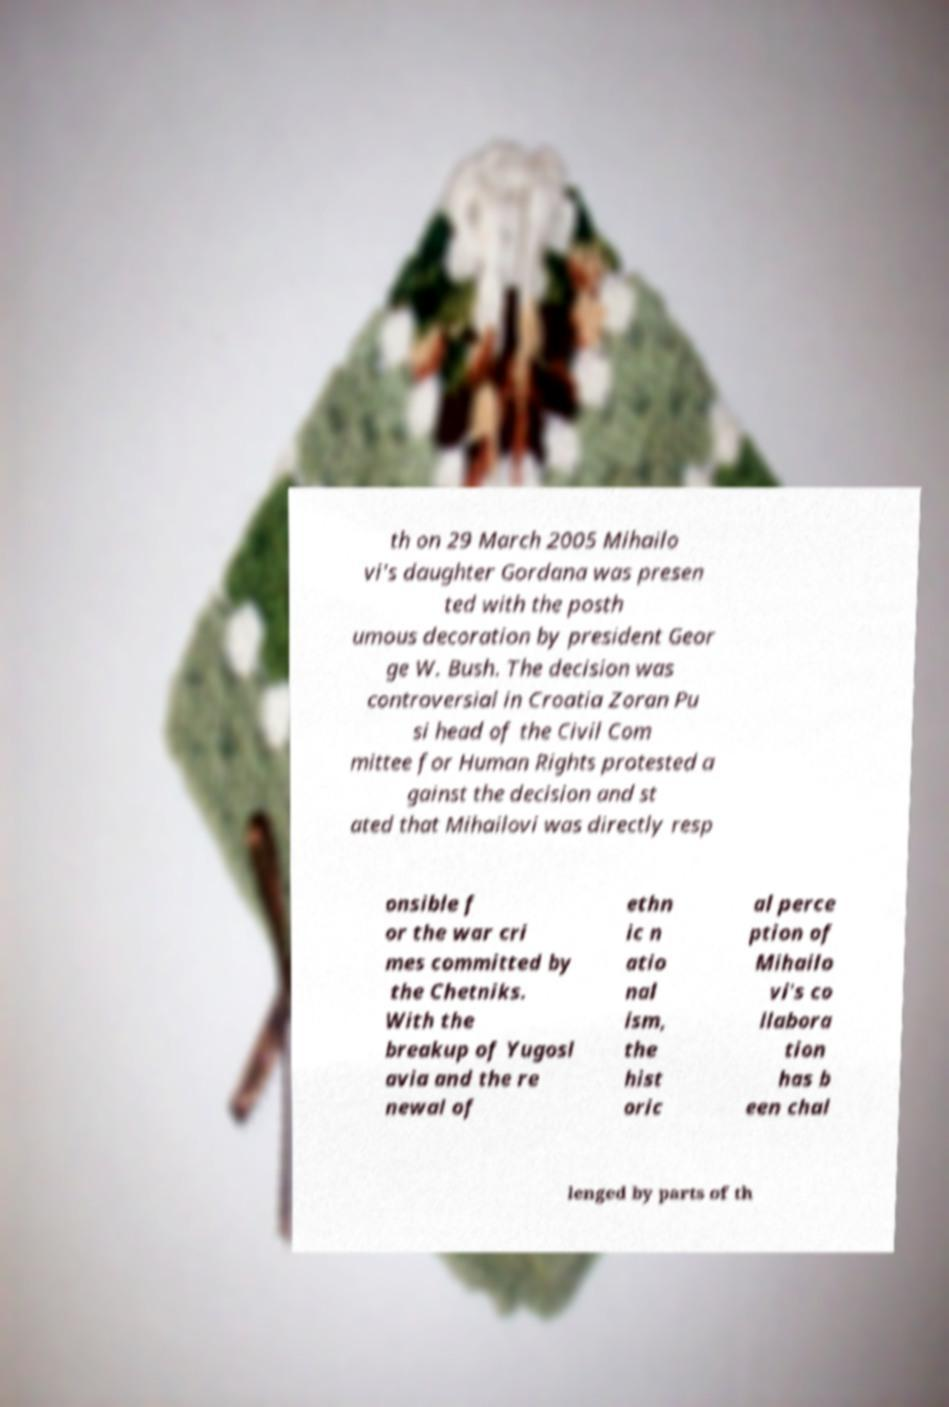Can you read and provide the text displayed in the image?This photo seems to have some interesting text. Can you extract and type it out for me? th on 29 March 2005 Mihailo vi's daughter Gordana was presen ted with the posth umous decoration by president Geor ge W. Bush. The decision was controversial in Croatia Zoran Pu si head of the Civil Com mittee for Human Rights protested a gainst the decision and st ated that Mihailovi was directly resp onsible f or the war cri mes committed by the Chetniks. With the breakup of Yugosl avia and the re newal of ethn ic n atio nal ism, the hist oric al perce ption of Mihailo vi's co llabora tion has b een chal lenged by parts of th 